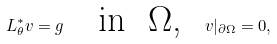<formula> <loc_0><loc_0><loc_500><loc_500>L _ { \theta } ^ { * } v = g \text { } \text { } \text { in } \text { $\Omega$, } \text { } v | _ { \partial \Omega } = 0 ,</formula> 